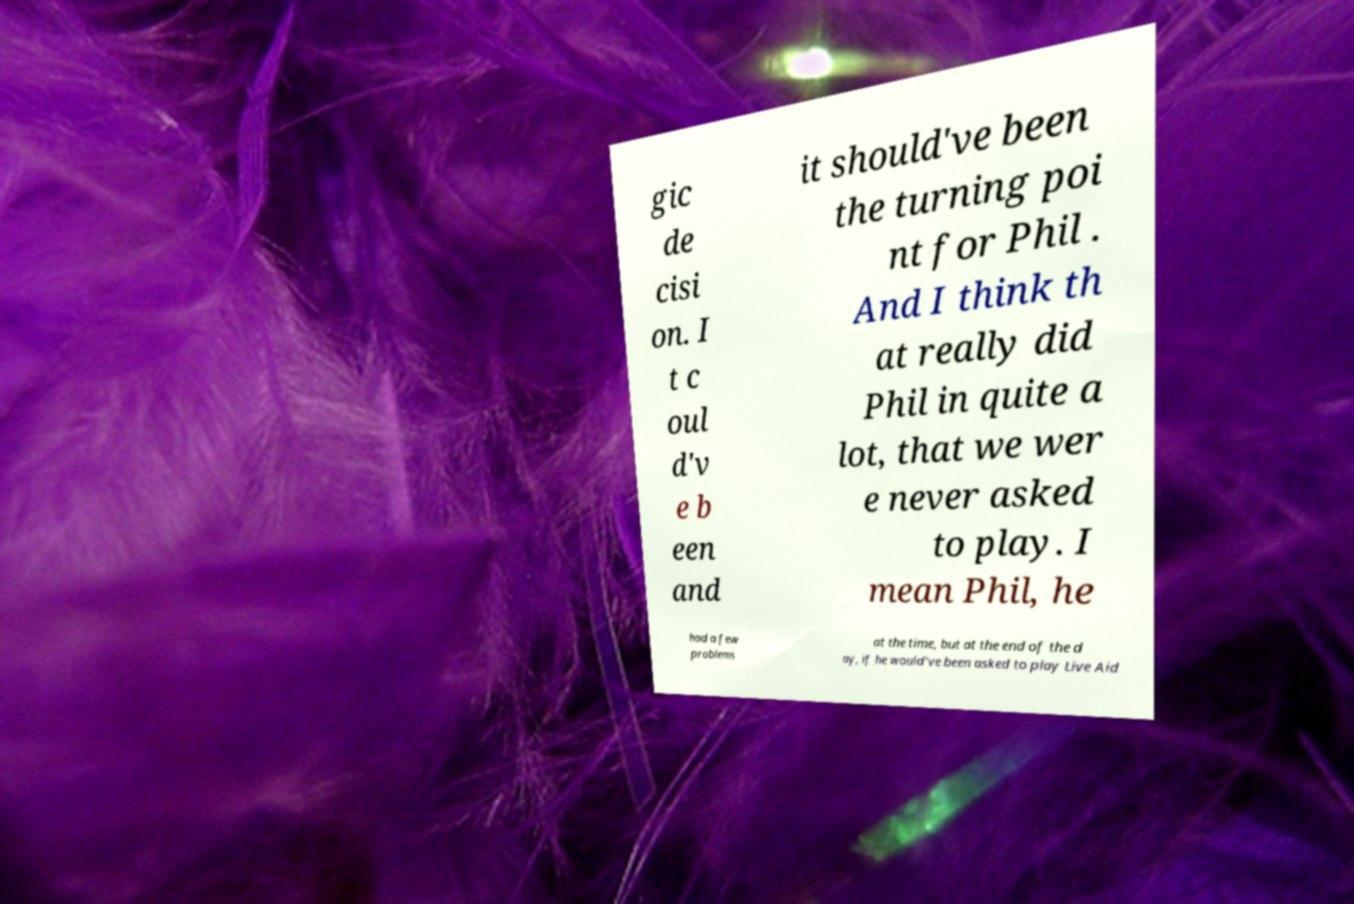Please identify and transcribe the text found in this image. gic de cisi on. I t c oul d'v e b een and it should've been the turning poi nt for Phil . And I think th at really did Phil in quite a lot, that we wer e never asked to play. I mean Phil, he had a few problems at the time, but at the end of the d ay, if he would've been asked to play Live Aid 